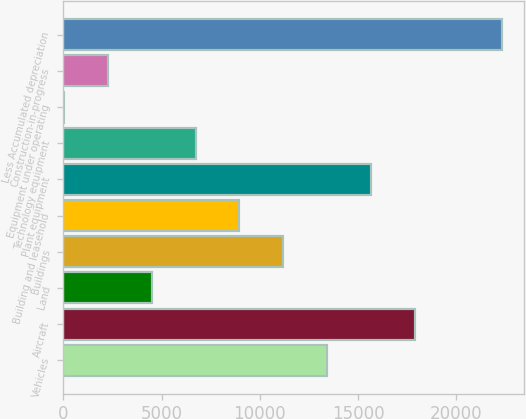<chart> <loc_0><loc_0><loc_500><loc_500><bar_chart><fcel>Vehicles<fcel>Aircraft<fcel>Land<fcel>Buildings<fcel>Building and leasehold<fcel>Plant equipment<fcel>Technology equipment<fcel>Equipment under operating<fcel>Construction-in-progress<fcel>Less Accumulated depreciation<nl><fcel>13417<fcel>17878<fcel>4495<fcel>11186.5<fcel>8956<fcel>15647.5<fcel>6725.5<fcel>34<fcel>2264.5<fcel>22339<nl></chart> 